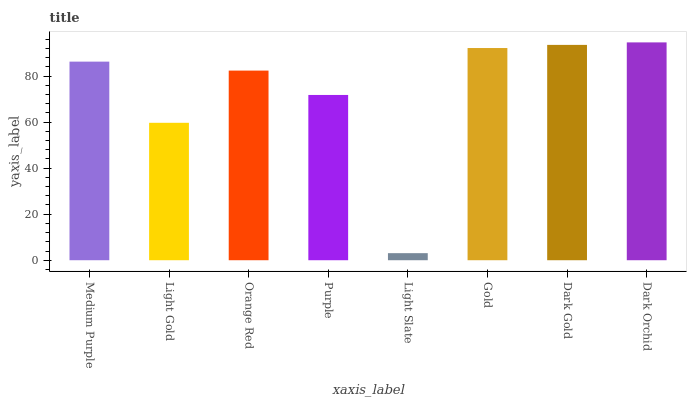Is Light Slate the minimum?
Answer yes or no. Yes. Is Dark Orchid the maximum?
Answer yes or no. Yes. Is Light Gold the minimum?
Answer yes or no. No. Is Light Gold the maximum?
Answer yes or no. No. Is Medium Purple greater than Light Gold?
Answer yes or no. Yes. Is Light Gold less than Medium Purple?
Answer yes or no. Yes. Is Light Gold greater than Medium Purple?
Answer yes or no. No. Is Medium Purple less than Light Gold?
Answer yes or no. No. Is Medium Purple the high median?
Answer yes or no. Yes. Is Orange Red the low median?
Answer yes or no. Yes. Is Gold the high median?
Answer yes or no. No. Is Medium Purple the low median?
Answer yes or no. No. 